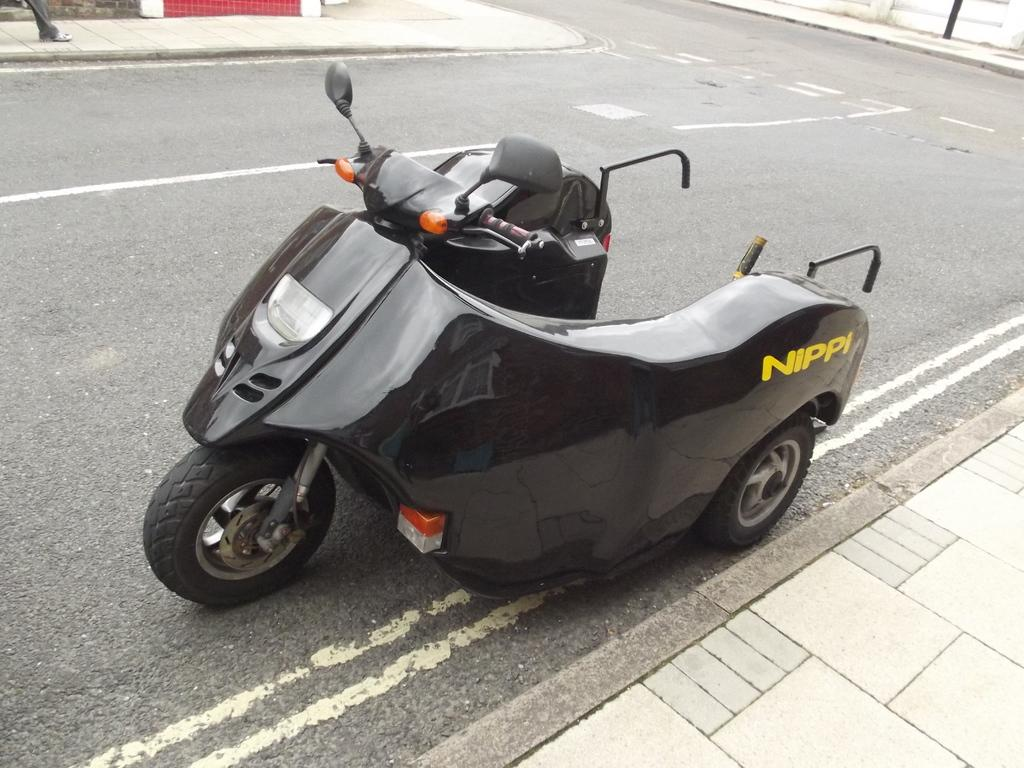What is the main subject of the image? There is a vehicle in the image. Where is the vehicle located? The vehicle is on the road. What language is the vehicle speaking in the image? Vehicles do not speak languages, so this question cannot be answered. 